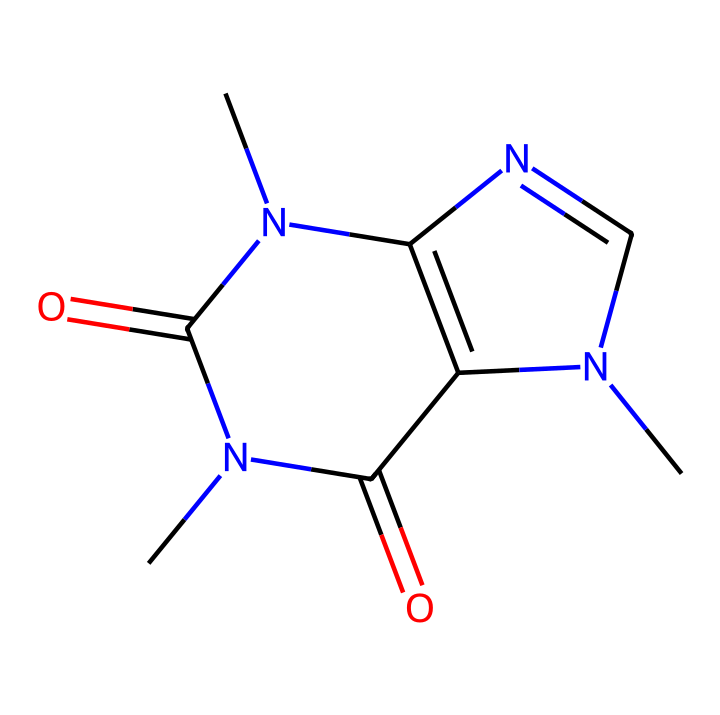How many nitrogen atoms are present in this chemical structure? By analyzing the structure, we see that nitrogen (N) appears in multiple locations in the chemical formula. Specifically, the SMILES representation indicates that there are two nitrogen atoms.
Answer: 2 What is the total number of carbon atoms in this chemical? The SMILES representation indicates the presence of multiple carbon atoms. By counting each occurrence, we find there are six carbon atoms in the chemical structure.
Answer: 6 Is this chemical an alkaloid? The chemical contains nitrogen atoms and is derived from natural sources like kola nuts, which classifies it as an alkaloid, a group known for their physiological effects and often bitter taste due to nitrogen content.
Answer: Yes What type of functional groups are present in this chemical? Analyzing the structure, we see that it contains carbonyl groups (C=O) and amine groups (N-H or C-N), which are typical functional groups found in many organic compounds, particularly in alkaloids.
Answer: Carbonyl and amine How many double bonds are there in the chemical structure? By reviewing the SMILES, we identify the double bonds specifically around the nitrogen and carbon atoms in the structure, leading us to find a total of three double bonds in the molecule.
Answer: 3 What characteristic does caffeine confer that affects human physiology? The presence of nitrogen atoms which interact with receptor systems in the human body contributing to stimulatory effects is a prime factor. This molecular structure allows it to block adenosine receptors, leading to increased alertness.
Answer: Stimulant 